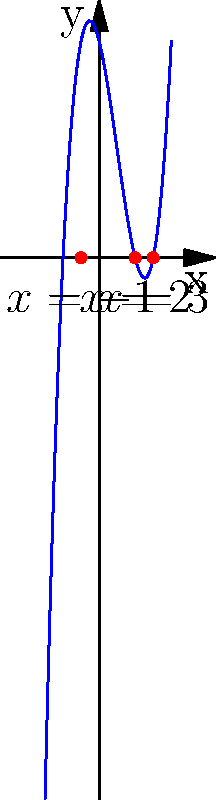The polynomial $f(x) = x^3 - 3x^2 - 4x + 12$ represents the challenges in an immigration process, where the roots symbolize successful outcomes. If the roots of this polynomial equation represent the number of years it takes to overcome different hurdles, what is the total number of years it would take to overcome all challenges in this immigration process? To solve this problem, we need to follow these steps:

1) First, we need to identify the roots of the polynomial equation. From the graph, we can see that the roots are at $x = -1$, $x = 2$, and $x = 3$.

2) These roots represent the number of years it takes to overcome each hurdle in the immigration process.

3) To find the total number of years to overcome all challenges, we need to sum up all the positive roots. We don't consider negative roots as time cannot be negative.

4) The positive roots are 2 and 3.

5) Therefore, the total number of years is: $2 + 3 = 5$ years.

This result symbolizes that it would take a total of 5 years to overcome all the significant hurdles in this particular immigration process.
Answer: 5 years 